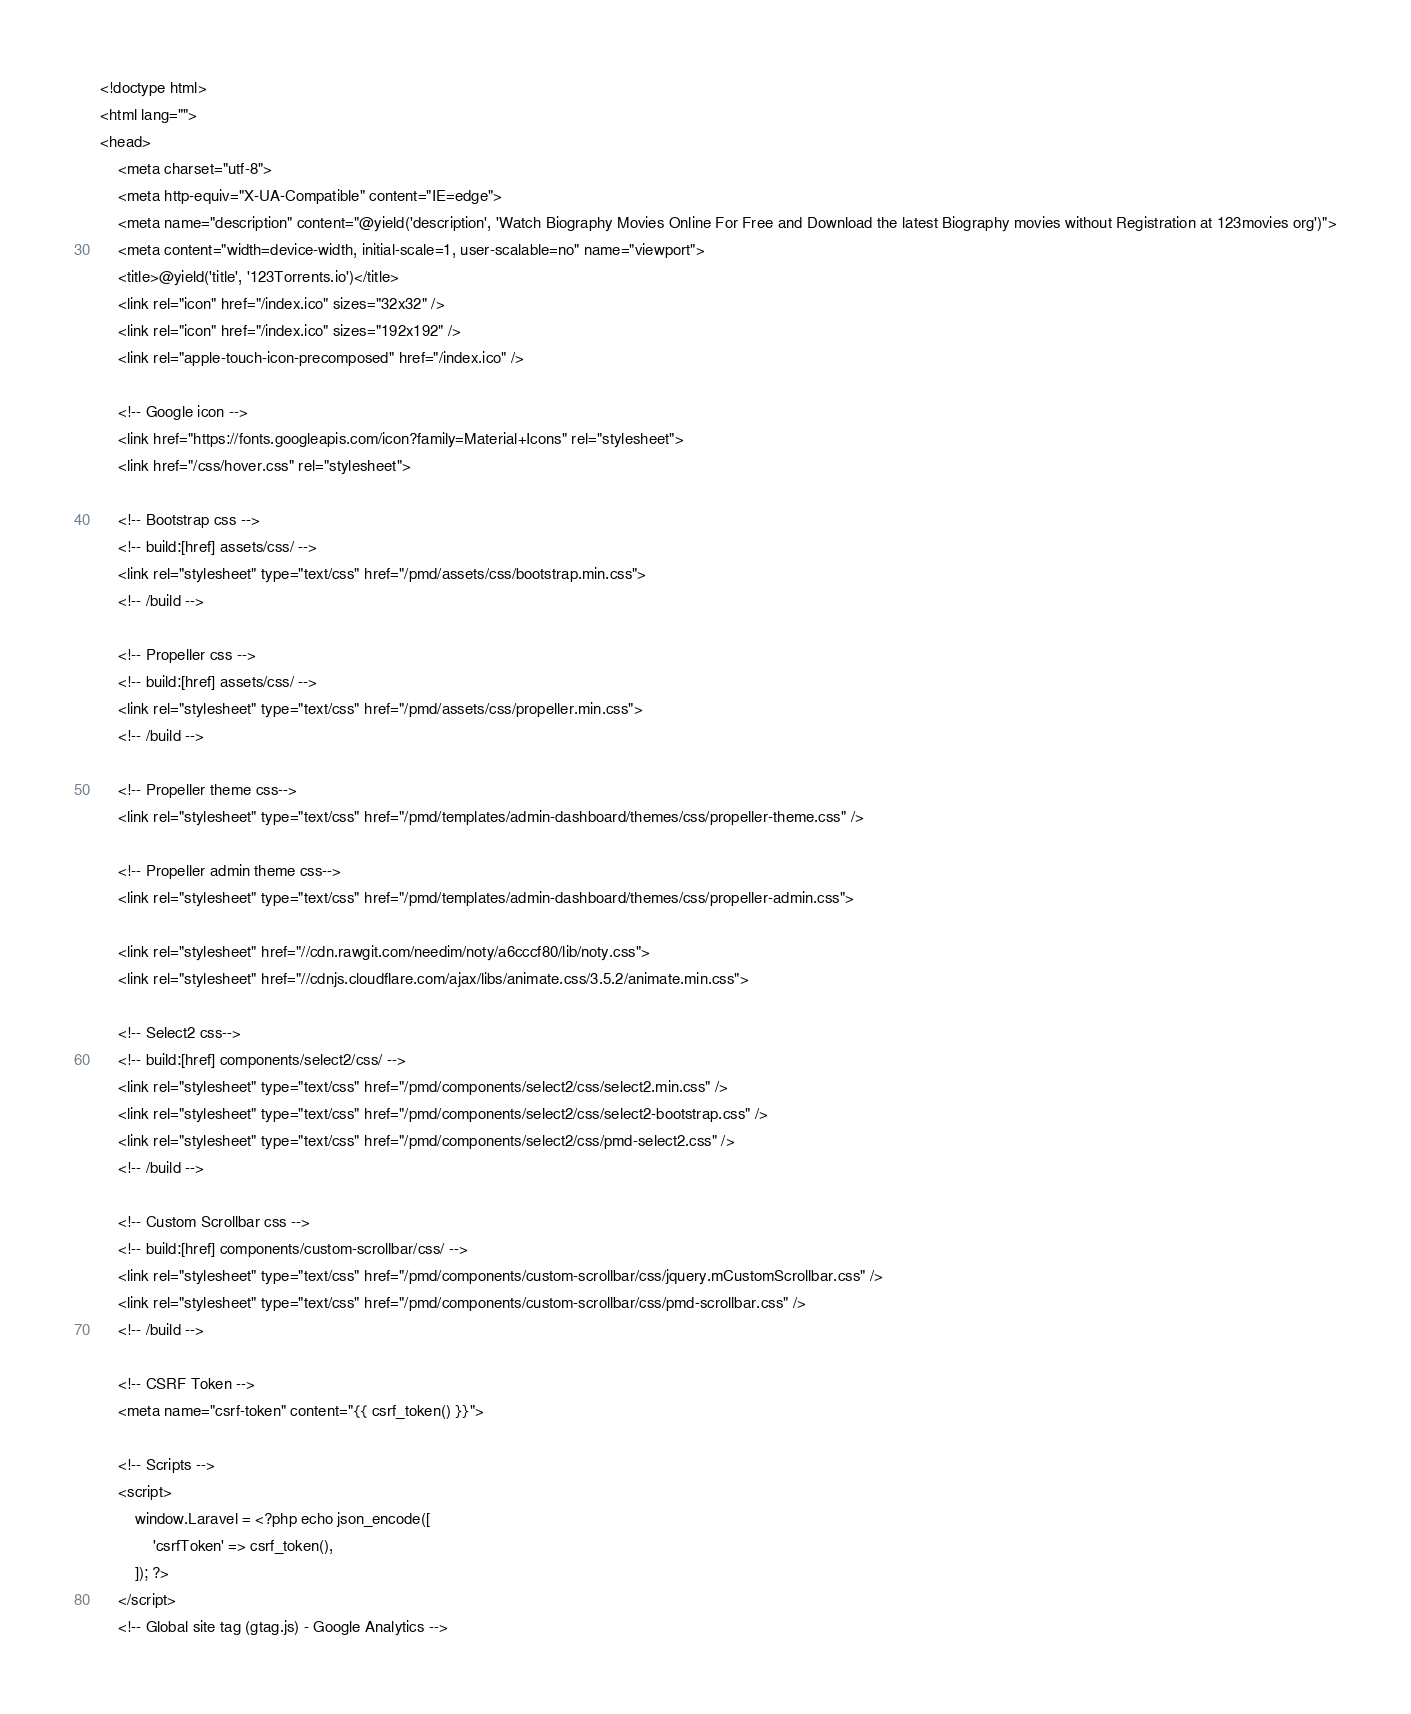<code> <loc_0><loc_0><loc_500><loc_500><_PHP_><!doctype html>
<html lang="">
<head>
    <meta charset="utf-8">
    <meta http-equiv="X-UA-Compatible" content="IE=edge">
    <meta name="description" content="@yield('description', 'Watch Biography Movies Online For Free and Download the latest Biography movies without Registration at 123movies org')">
    <meta content="width=device-width, initial-scale=1, user-scalable=no" name="viewport">
    <title>@yield('title', '123Torrents.io')</title>
    <link rel="icon" href="/index.ico" sizes="32x32" />
    <link rel="icon" href="/index.ico" sizes="192x192" />
    <link rel="apple-touch-icon-precomposed" href="/index.ico" />

    <!-- Google icon -->
    <link href="https://fonts.googleapis.com/icon?family=Material+Icons" rel="stylesheet">
    <link href="/css/hover.css" rel="stylesheet">

    <!-- Bootstrap css -->
    <!-- build:[href] assets/css/ -->
    <link rel="stylesheet" type="text/css" href="/pmd/assets/css/bootstrap.min.css">
    <!-- /build -->

    <!-- Propeller css -->
    <!-- build:[href] assets/css/ -->
    <link rel="stylesheet" type="text/css" href="/pmd/assets/css/propeller.min.css">
    <!-- /build -->

    <!-- Propeller theme css-->
    <link rel="stylesheet" type="text/css" href="/pmd/templates/admin-dashboard/themes/css/propeller-theme.css" />

    <!-- Propeller admin theme css-->
    <link rel="stylesheet" type="text/css" href="/pmd/templates/admin-dashboard/themes/css/propeller-admin.css">

    <link rel="stylesheet" href="//cdn.rawgit.com/needim/noty/a6cccf80/lib/noty.css">
    <link rel="stylesheet" href="//cdnjs.cloudflare.com/ajax/libs/animate.css/3.5.2/animate.min.css">

    <!-- Select2 css-->
    <!-- build:[href] components/select2/css/ -->
    <link rel="stylesheet" type="text/css" href="/pmd/components/select2/css/select2.min.css" />
    <link rel="stylesheet" type="text/css" href="/pmd/components/select2/css/select2-bootstrap.css" />
    <link rel="stylesheet" type="text/css" href="/pmd/components/select2/css/pmd-select2.css" />
    <!-- /build -->

    <!-- Custom Scrollbar css -->
    <!-- build:[href] components/custom-scrollbar/css/ -->
    <link rel="stylesheet" type="text/css" href="/pmd/components/custom-scrollbar/css/jquery.mCustomScrollbar.css" />
    <link rel="stylesheet" type="text/css" href="/pmd/components/custom-scrollbar/css/pmd-scrollbar.css" />
    <!-- /build -->

    <!-- CSRF Token -->
    <meta name="csrf-token" content="{{ csrf_token() }}">

    <!-- Scripts -->
    <script>
        window.Laravel = <?php echo json_encode([
            'csrfToken' => csrf_token(),
        ]); ?>
    </script>
    <!-- Global site tag (gtag.js) - Google Analytics --></code> 